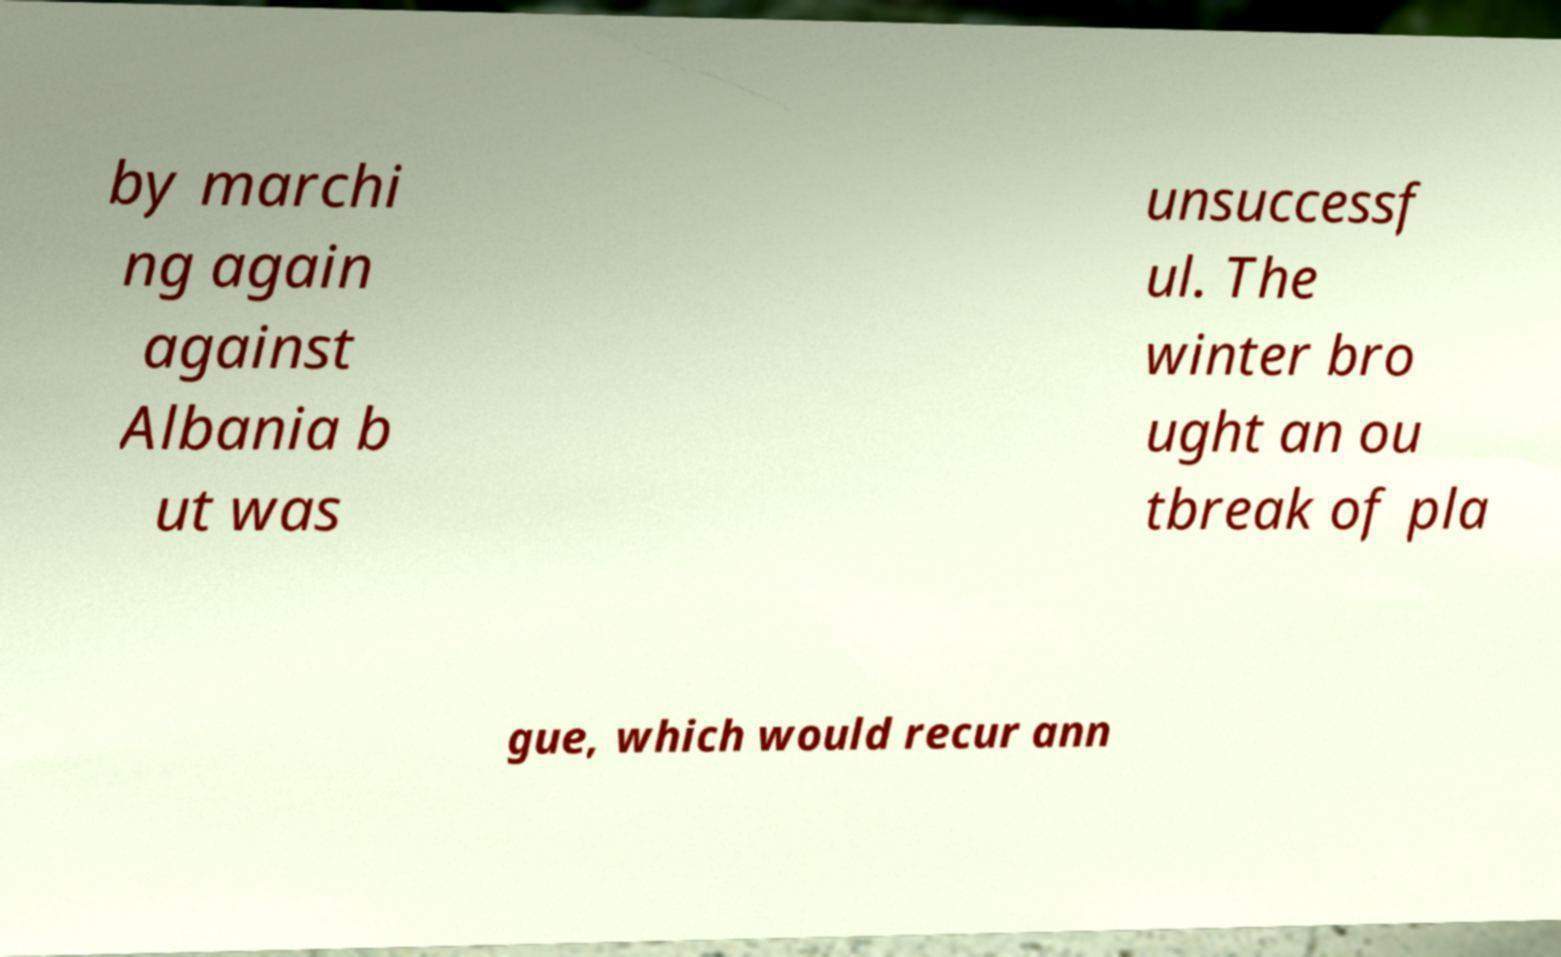I need the written content from this picture converted into text. Can you do that? by marchi ng again against Albania b ut was unsuccessf ul. The winter bro ught an ou tbreak of pla gue, which would recur ann 